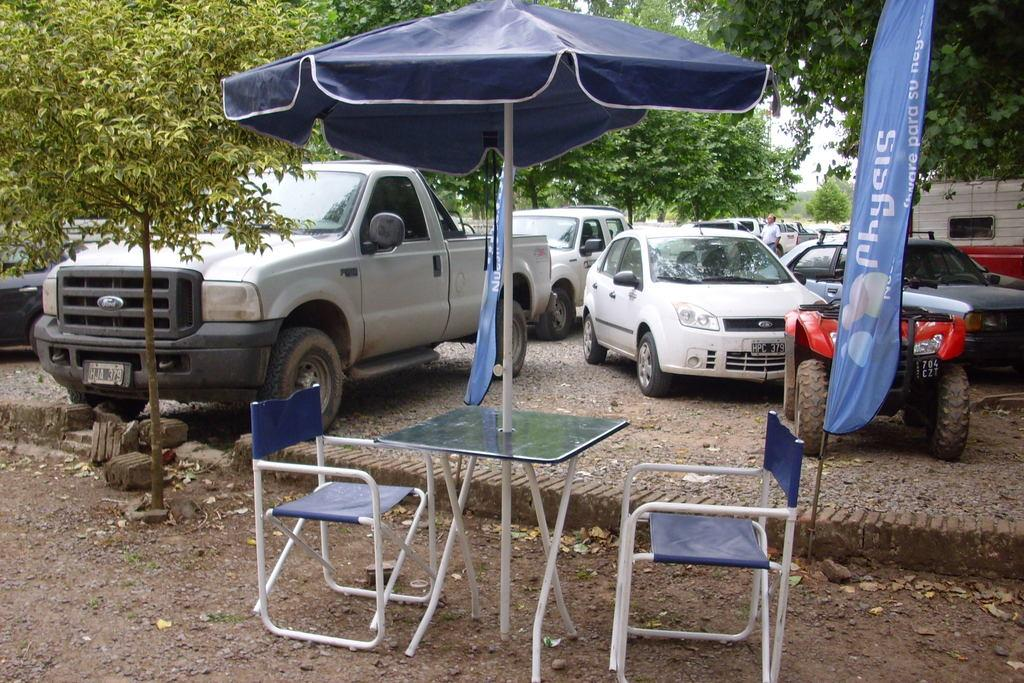What type of vehicles can be seen in the image? There are cars and a truck in the image. Where is the truck located in the image? The truck is in the middle of the image. What object is visible that might be used for protection from the rain? An umbrella is visible in the image. How many chairs are present in the image? Two chairs are present in the image. What piece of furniture is in the image that might be used for eating or working? A table is in the image. What can be seen in the background of the image? Trees and a person are visible in the background of the image. What type of quill is being used by the person in the image? There is no quill present in the image; it is not a historical scene or a setting where a quill would be used. 